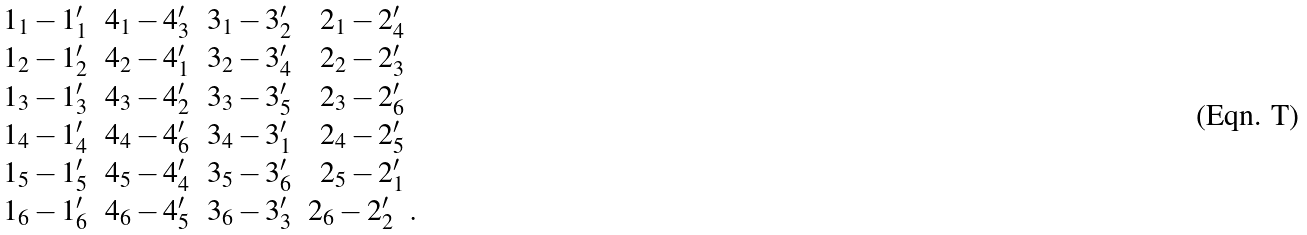<formula> <loc_0><loc_0><loc_500><loc_500>\begin{array} { c c c c } 1 _ { 1 } - 1 ^ { \prime } _ { 1 } & 4 _ { 1 } - 4 ^ { \prime } _ { 3 } & 3 _ { 1 } - 3 ^ { \prime } _ { 2 } & 2 _ { 1 } - 2 ^ { \prime } _ { 4 } \\ 1 _ { 2 } - 1 ^ { \prime } _ { 2 } & 4 _ { 2 } - 4 ^ { \prime } _ { 1 } & 3 _ { 2 } - 3 ^ { \prime } _ { 4 } & 2 _ { 2 } - 2 ^ { \prime } _ { 3 } \\ 1 _ { 3 } - 1 ^ { \prime } _ { 3 } & 4 _ { 3 } - 4 ^ { \prime } _ { 2 } & 3 _ { 3 } - 3 ^ { \prime } _ { 5 } & 2 _ { 3 } - 2 ^ { \prime } _ { 6 } \\ 1 _ { 4 } - 1 ^ { \prime } _ { 4 } & 4 _ { 4 } - 4 ^ { \prime } _ { 6 } & 3 _ { 4 } - 3 ^ { \prime } _ { 1 } & 2 _ { 4 } - 2 ^ { \prime } _ { 5 } \\ 1 _ { 5 } - 1 ^ { \prime } _ { 5 } & 4 _ { 5 } - 4 ^ { \prime } _ { 4 } & 3 _ { 5 } - 3 ^ { \prime } _ { 6 } & 2 _ { 5 } - 2 ^ { \prime } _ { 1 } \\ 1 _ { 6 } - 1 ^ { \prime } _ { 6 } & 4 _ { 6 } - 4 ^ { \prime } _ { 5 } & 3 _ { 6 } - 3 ^ { \prime } _ { 3 } & 2 _ { 6 } - 2 ^ { \prime } _ { 2 } \ \ . \\ \end{array}</formula> 